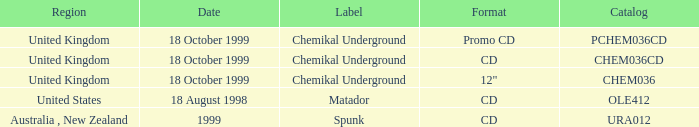What identifier is related to the united kingdom and the chem036 catalog? Chemikal Underground. 